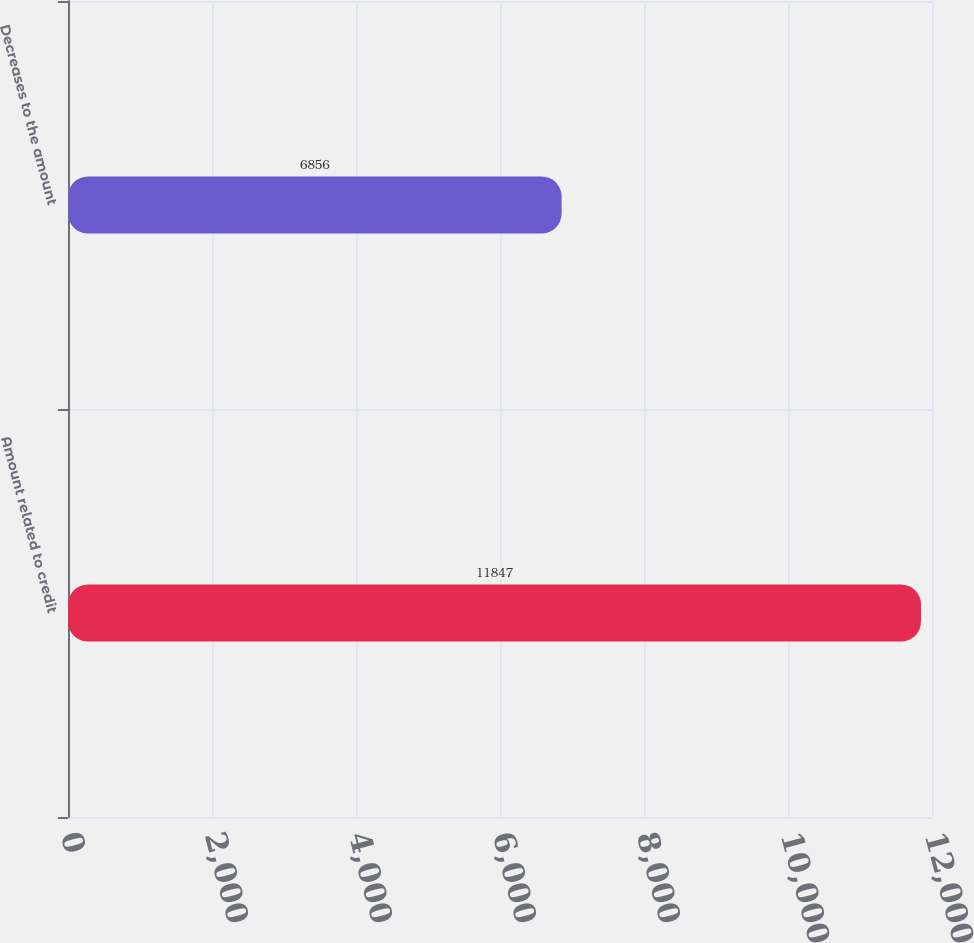Convert chart. <chart><loc_0><loc_0><loc_500><loc_500><bar_chart><fcel>Amount related to credit<fcel>Decreases to the amount<nl><fcel>11847<fcel>6856<nl></chart> 